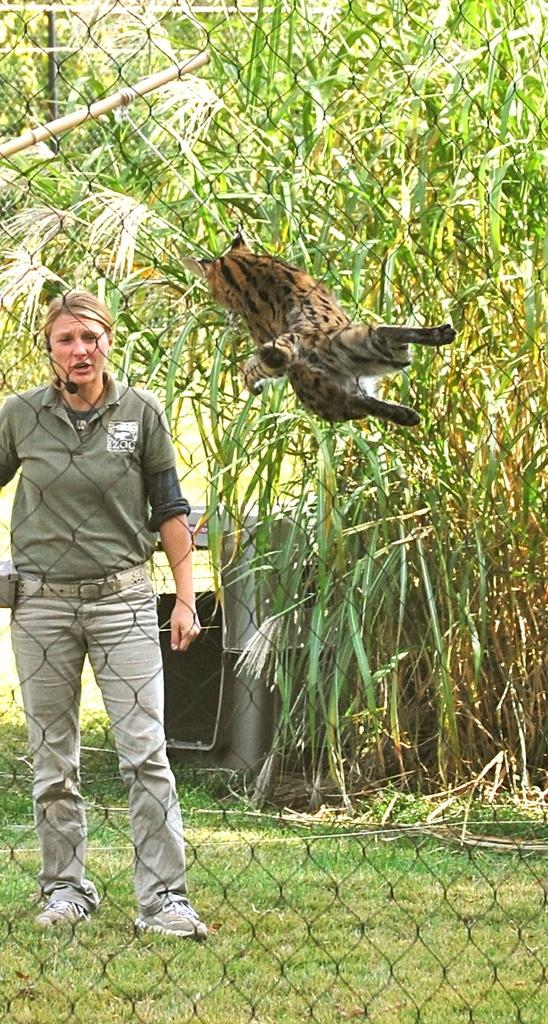What is the main subject in the image? There is a person standing in the image. What other living creature is present in the image? There is an animal in the image. What can be seen in the background of the image? There are trees in the background of the image. What else can be observed in the image? There are objects in the image. Is there a slave depicted in the image? No, there is no mention or indication of a slave in the image. How many deer are visible in the image? There is no deer present in the image. 